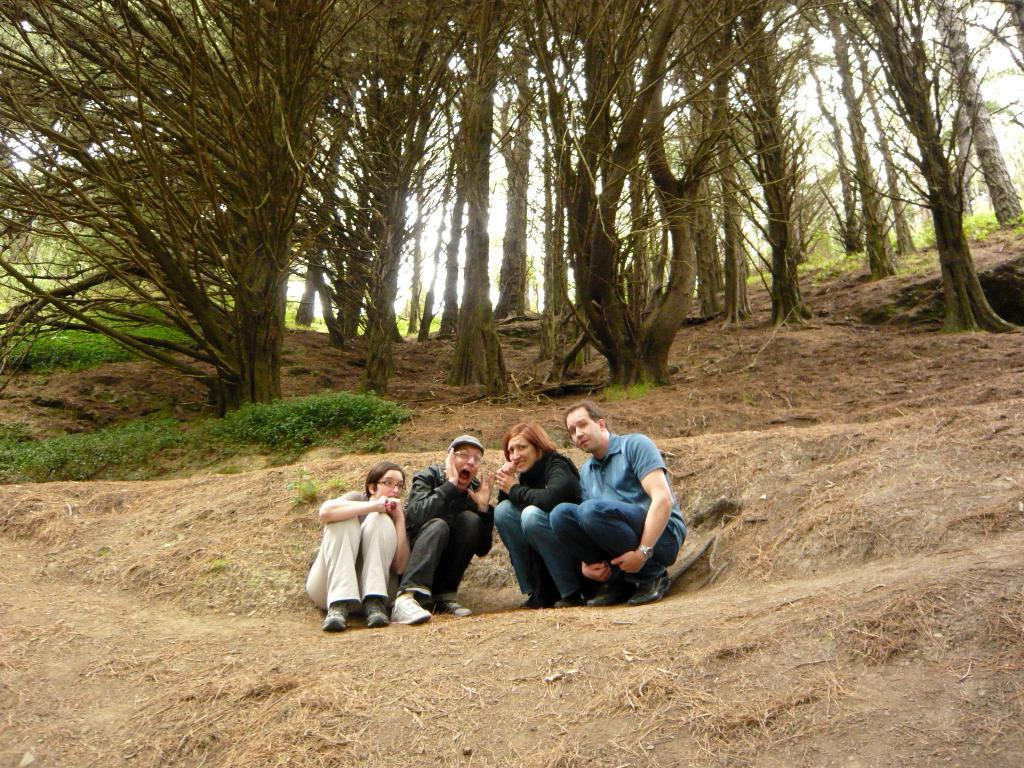How many people are present in the image? There are four people in the image. What is the ground covered with in the image? There is dry grass on the ground. Are there any plants visible in the image? Yes, there are a few plants in the image. What can be seen in the background of the image? Trees are visible in the background of the image. Is there any salt visible on the ground in the image? No, there is no salt visible on the ground in the image. Is the image showing a snowy environment? No, the image does not show a snowy environment; it features dry grass on the ground. 